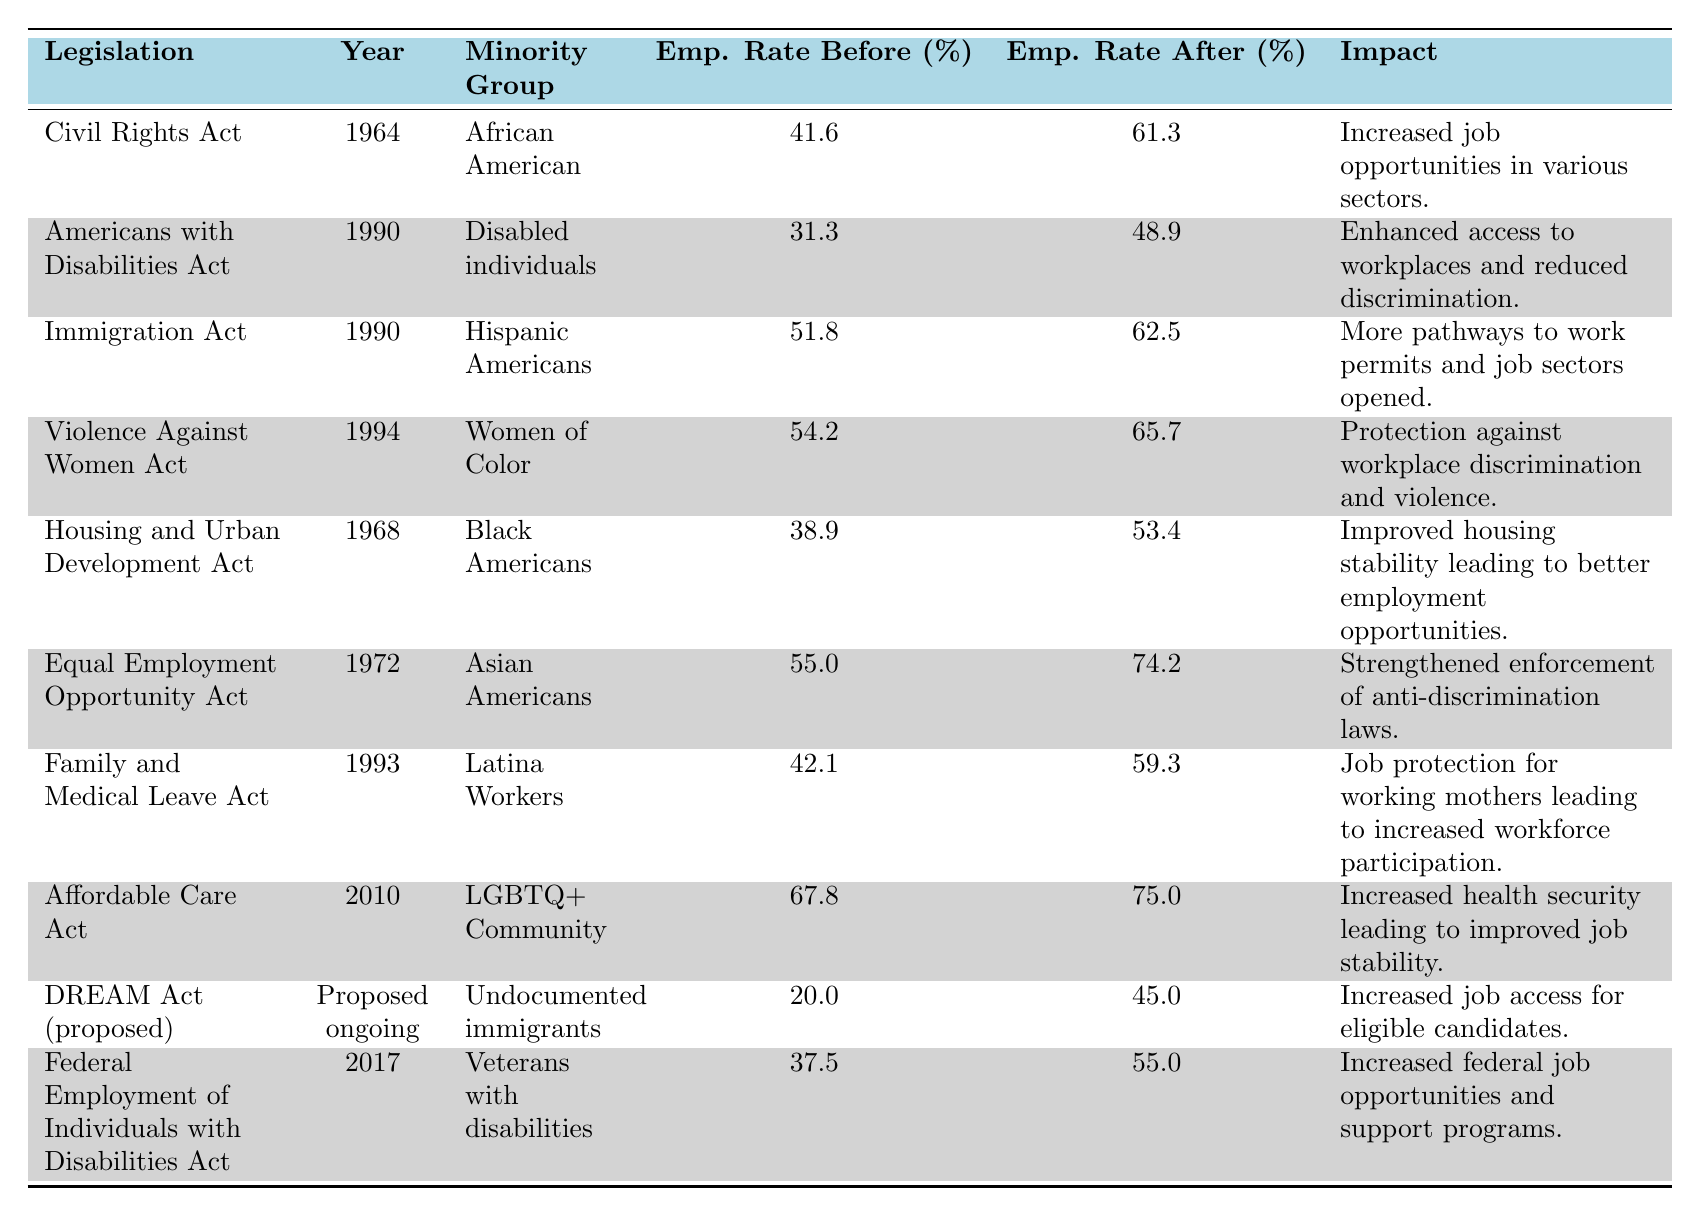What was the employment rate for African Americans before the Civil Rights Act of 1964? The table shows that the employment rate for African Americans before the Civil Rights Act of 1964 was 41.6%.
Answer: 41.6% What was the impact of the Affordable Care Act of 2010 on the employment rate of the LGBTQ+ Community? The table indicates that the employment rate for the LGBTQ+ Community increased from 67.8% to 75.0% after the Affordable Care Act of 2010, implying the impact was positive.
Answer: Increased to 75.0% What minority group had the highest employment rate after their respective legislation? Upon comparing the employment rates after the enactments, Asian Americans had the highest employment rate at 74.2% following the Equal Employment Opportunity Act of 1972.
Answer: Asian Americans (74.2%) What was the percentage increase in employment rates for Disabled individuals after the Americans with Disabilities Act of 1990? The employment rate before was 31.3% and after was 48.9%, so the increase is calculated as: 48.9% - 31.3% = 17.6%.
Answer: 17.6% Did the employment rate for undocumented immigrants increase after the DREAM Act was proposed? Yes, the employment rate increased from 20.0% before the proposal to 45.0% after. This indicates a positive change.
Answer: Yes Which legislation had the greatest impact (largest percentage increase) on employment rates for minority groups? Analyzing the employment rate increases: Civil Rights Act (19.7%), Americans with Disabilities Act (17.6%), Immigration Act (10.7%), Violence Against Women Act (11.5%), Equal Employment Opportunity Act (19.2%). The Civil Rights Act had the highest increase of 19.7%.
Answer: Civil Rights Act of 1964 (19.7%) What was the employment rate for Women of Color before the Violence Against Women Act of 1994? The employment rate for Women of Color before the Violence Against Women Act of 1994 was 54.2%.
Answer: 54.2% Calculate the average employment rate after the legislation for all minority groups listed. Summing the employment rates after legislation: 61.3 + 48.9 + 62.5 + 65.7 + 53.4 + 74.2 + 59.3 + 75.0 + 45.0 + 55.0 = 622.0. There are 10 entries, so the average is 622.0/10 = 62.2.
Answer: 62.2 Is it true that the employment rate for African Americans increased by more than 20% after the Civil Rights Act of 1964? True, the employment rate increased from 41.6% to 61.3%, which is more than a 20% increase (19.7%).
Answer: True What was the employment rate for Latina Workers before the Family and Medical Leave Act of 1993? The table shows that the employment rate for Latina Workers before the Family and Medical Leave Act of 1993 was 42.1%.
Answer: 42.1% 